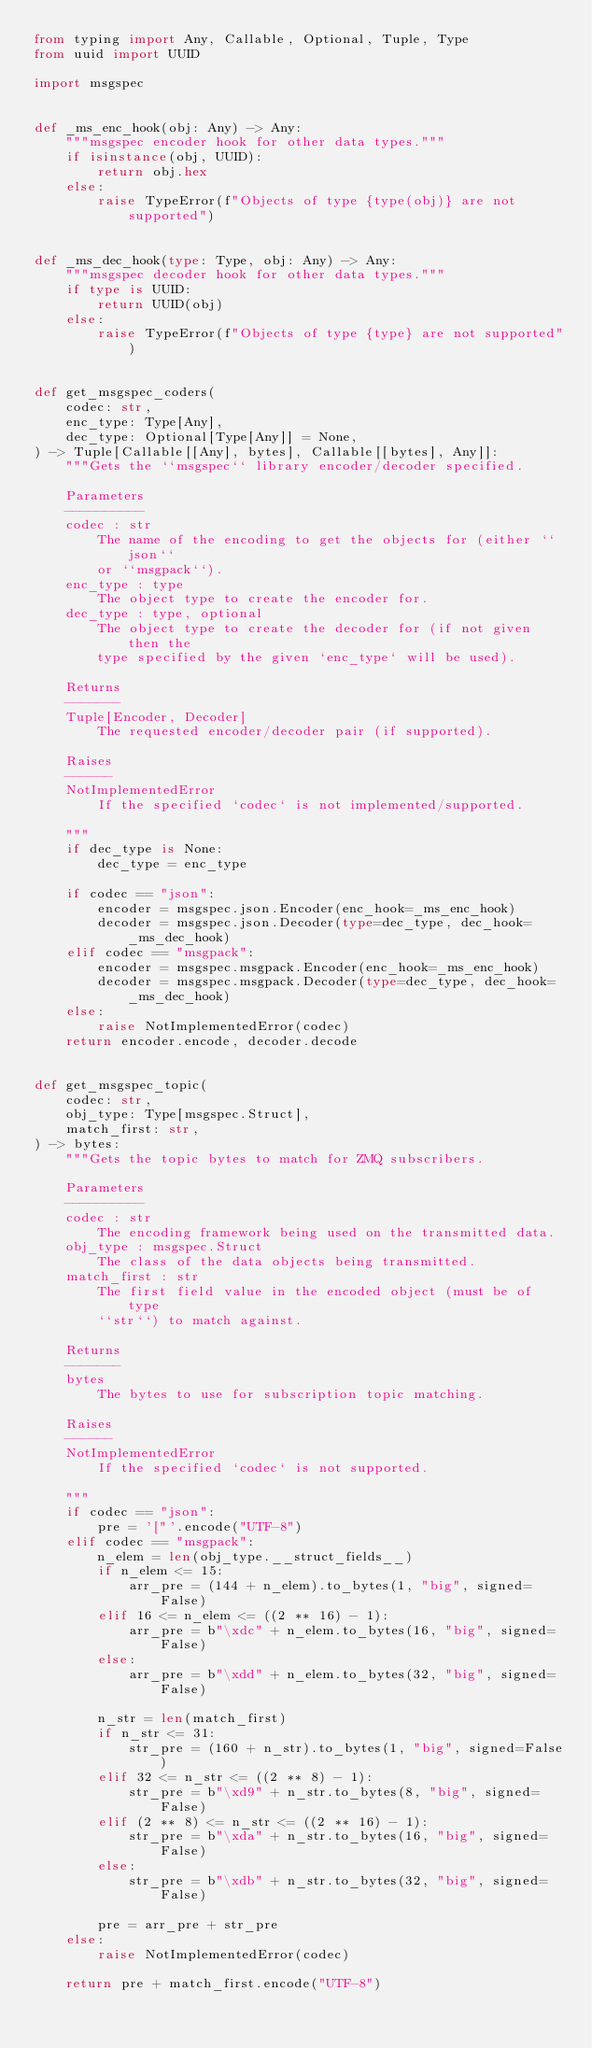Convert code to text. <code><loc_0><loc_0><loc_500><loc_500><_Python_>from typing import Any, Callable, Optional, Tuple, Type
from uuid import UUID

import msgspec


def _ms_enc_hook(obj: Any) -> Any:
    """msgspec encoder hook for other data types."""
    if isinstance(obj, UUID):
        return obj.hex
    else:
        raise TypeError(f"Objects of type {type(obj)} are not supported")


def _ms_dec_hook(type: Type, obj: Any) -> Any:
    """msgspec decoder hook for other data types."""
    if type is UUID:
        return UUID(obj)
    else:
        raise TypeError(f"Objects of type {type} are not supported")


def get_msgspec_coders(
    codec: str,
    enc_type: Type[Any],
    dec_type: Optional[Type[Any]] = None,
) -> Tuple[Callable[[Any], bytes], Callable[[bytes], Any]]:
    """Gets the ``msgspec`` library encoder/decoder specified.

    Parameters
    ----------
    codec : str
        The name of the encoding to get the objects for (either ``json``
        or ``msgpack``).
    enc_type : type
        The object type to create the encoder for.
    dec_type : type, optional
        The object type to create the decoder for (if not given then the
        type specified by the given `enc_type` will be used).

    Returns
    -------
    Tuple[Encoder, Decoder]
        The requested encoder/decoder pair (if supported).

    Raises
    ------
    NotImplementedError
        If the specified `codec` is not implemented/supported.

    """
    if dec_type is None:
        dec_type = enc_type

    if codec == "json":
        encoder = msgspec.json.Encoder(enc_hook=_ms_enc_hook)
        decoder = msgspec.json.Decoder(type=dec_type, dec_hook=_ms_dec_hook)
    elif codec == "msgpack":
        encoder = msgspec.msgpack.Encoder(enc_hook=_ms_enc_hook)
        decoder = msgspec.msgpack.Decoder(type=dec_type, dec_hook=_ms_dec_hook)
    else:
        raise NotImplementedError(codec)
    return encoder.encode, decoder.decode


def get_msgspec_topic(
    codec: str,
    obj_type: Type[msgspec.Struct],
    match_first: str,
) -> bytes:
    """Gets the topic bytes to match for ZMQ subscribers.

    Parameters
    ----------
    codec : str
        The encoding framework being used on the transmitted data.
    obj_type : msgspec.Struct
        The class of the data objects being transmitted.
    match_first : str
        The first field value in the encoded object (must be of type
        ``str``) to match against.

    Returns
    -------
    bytes
        The bytes to use for subscription topic matching.

    Raises
    ------
    NotImplementedError
        If the specified `codec` is not supported.

    """
    if codec == "json":
        pre = '["'.encode("UTF-8")
    elif codec == "msgpack":
        n_elem = len(obj_type.__struct_fields__)
        if n_elem <= 15:
            arr_pre = (144 + n_elem).to_bytes(1, "big", signed=False)
        elif 16 <= n_elem <= ((2 ** 16) - 1):
            arr_pre = b"\xdc" + n_elem.to_bytes(16, "big", signed=False)
        else:
            arr_pre = b"\xdd" + n_elem.to_bytes(32, "big", signed=False)

        n_str = len(match_first)
        if n_str <= 31:
            str_pre = (160 + n_str).to_bytes(1, "big", signed=False)
        elif 32 <= n_str <= ((2 ** 8) - 1):
            str_pre = b"\xd9" + n_str.to_bytes(8, "big", signed=False)
        elif (2 ** 8) <= n_str <= ((2 ** 16) - 1):
            str_pre = b"\xda" + n_str.to_bytes(16, "big", signed=False)
        else:
            str_pre = b"\xdb" + n_str.to_bytes(32, "big", signed=False)

        pre = arr_pre + str_pre
    else:
        raise NotImplementedError(codec)

    return pre + match_first.encode("UTF-8")
</code> 